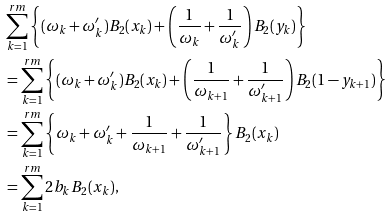Convert formula to latex. <formula><loc_0><loc_0><loc_500><loc_500>& \sum _ { k = 1 } ^ { r m } \left \{ ( \omega _ { k } + \omega _ { k } ^ { \prime } ) B _ { 2 } ( x _ { k } ) + \left ( \frac { 1 } { \omega _ { k } } + \frac { 1 } { \omega _ { k } ^ { \prime } } \right ) B _ { 2 } ( y _ { k } ) \right \} \\ & = \sum _ { k = 1 } ^ { r m } \left \{ ( \omega _ { k } + \omega _ { k } ^ { \prime } ) B _ { 2 } ( x _ { k } ) + \left ( \frac { 1 } { \omega _ { k + 1 } } + \frac { 1 } { \omega _ { k + 1 } ^ { \prime } } \right ) B _ { 2 } ( 1 - y _ { k + 1 } ) \right \} \\ & = \sum _ { k = 1 } ^ { r m } \left \{ \omega _ { k } + \omega _ { k } ^ { \prime } + \frac { 1 } { \omega _ { k + 1 } } + \frac { 1 } { \omega _ { k + 1 } ^ { \prime } } \right \} B _ { 2 } ( x _ { k } ) \\ & = \sum _ { k = 1 } ^ { r m } 2 b _ { k } B _ { 2 } ( x _ { k } ) ,</formula> 